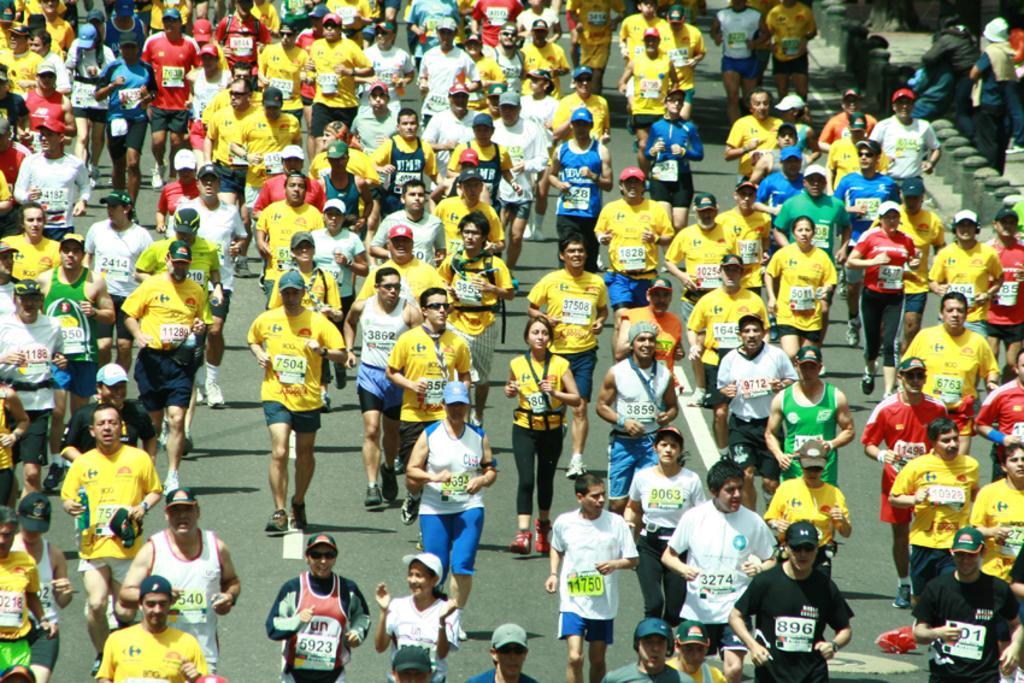Describe this image in one or two sentences. In this image there are many people walking on the road. 